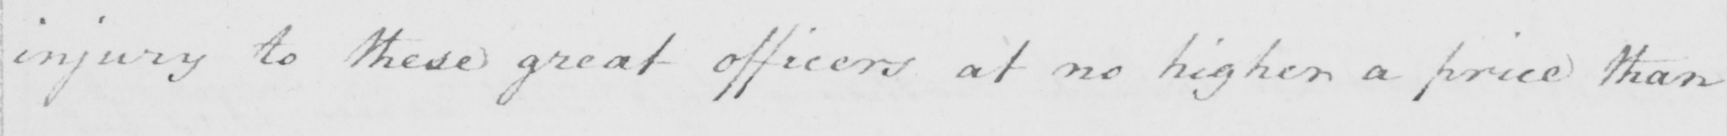Can you tell me what this handwritten text says? injury to these great officers at no higher a price than 